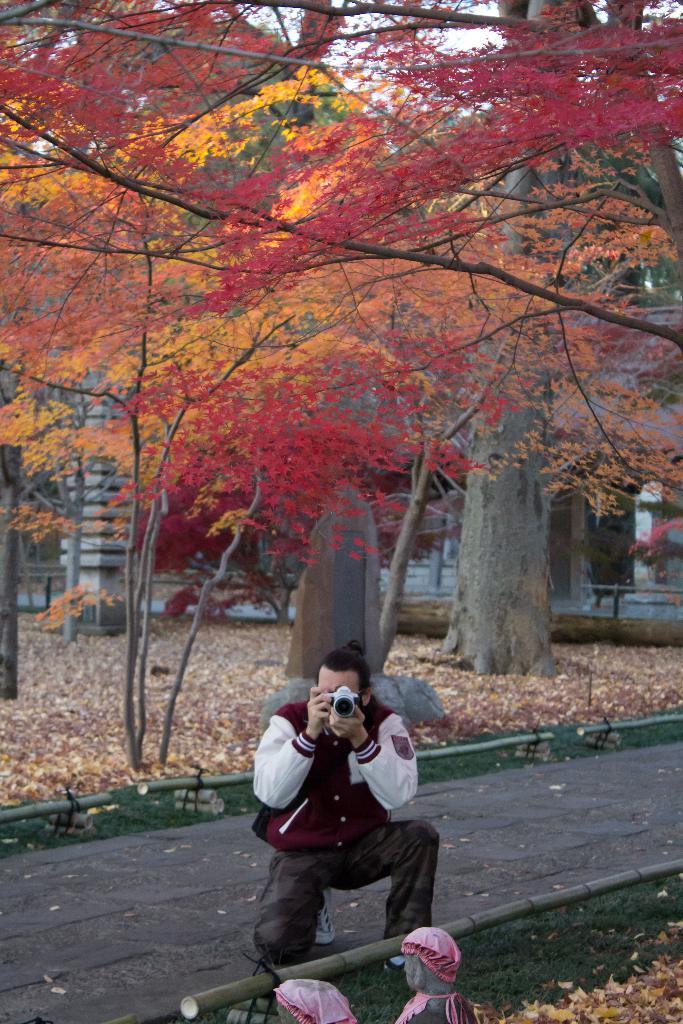How would you summarize this image in a sentence or two? In the foreground I can see a person is holding a camera in hand, statue, fence and grass. In the background I can see trees, pillar and the sky. This image is taken may be during a day. 